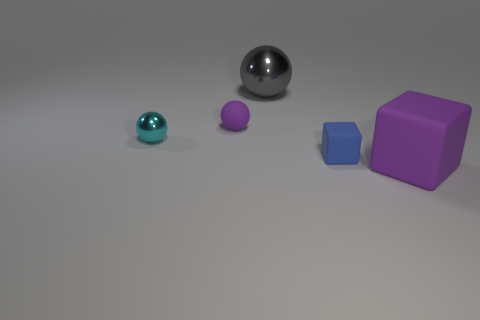Add 1 gray spheres. How many objects exist? 6 Subtract all metal balls. How many balls are left? 1 Subtract 1 blocks. How many blocks are left? 1 Subtract all spheres. How many objects are left? 2 Subtract all cyan spheres. How many spheres are left? 2 Subtract all tiny metallic balls. Subtract all small yellow matte cylinders. How many objects are left? 4 Add 4 blue rubber objects. How many blue rubber objects are left? 5 Add 1 small things. How many small things exist? 4 Subtract 1 purple balls. How many objects are left? 4 Subtract all purple balls. Subtract all brown cylinders. How many balls are left? 2 